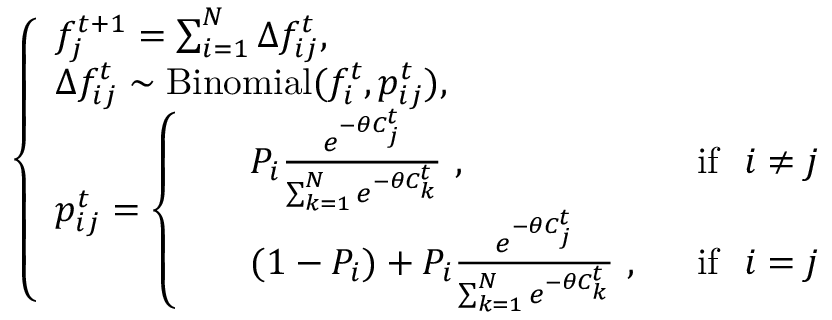<formula> <loc_0><loc_0><loc_500><loc_500>\left \{ \begin{array} { l l } { f _ { j } ^ { t + 1 } = \sum _ { i = 1 } ^ { N } \Delta f _ { i j } ^ { t } , } \\ { \Delta f _ { i j } ^ { t } \sim B i n o m i a l ( f _ { i } ^ { t } , { p } _ { i j } ^ { t } ) , } \\ { p _ { i j } ^ { t } = \left \{ \begin{array} { l l } { \begin{array} { r l r } & { P _ { i } \frac { e ^ { - \theta C _ { j } ^ { t } } } { \sum _ { k = 1 } ^ { N } e ^ { - \theta C _ { k } ^ { t } } } \ , \ } & { \ i f \ \ i \neq j } \\ & { ( 1 - P _ { i } ) + P _ { i } \frac { e ^ { - \theta C _ { j } ^ { t } } } { \sum _ { k = 1 } ^ { N } e ^ { - \theta C _ { k } ^ { t } } } \ , \ } & { \ i f \ \ i = j } \end{array} } \end{array} } \end{array}</formula> 